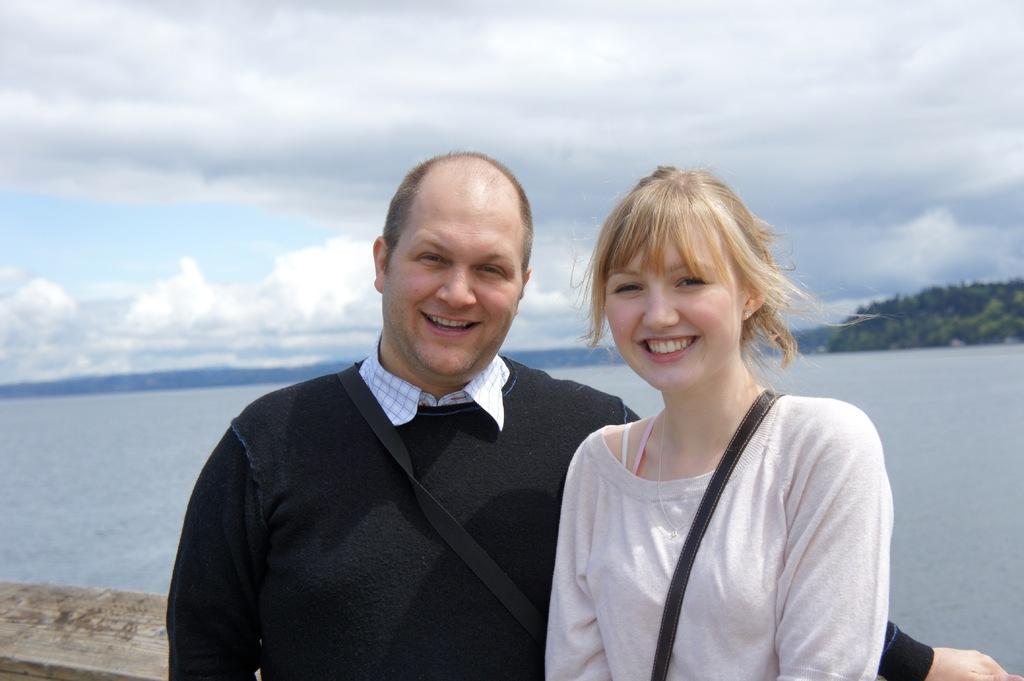Could you give a brief overview of what you see in this image? There is a man and a woman. Both are smiling. In the back there is water, hills and sky. 